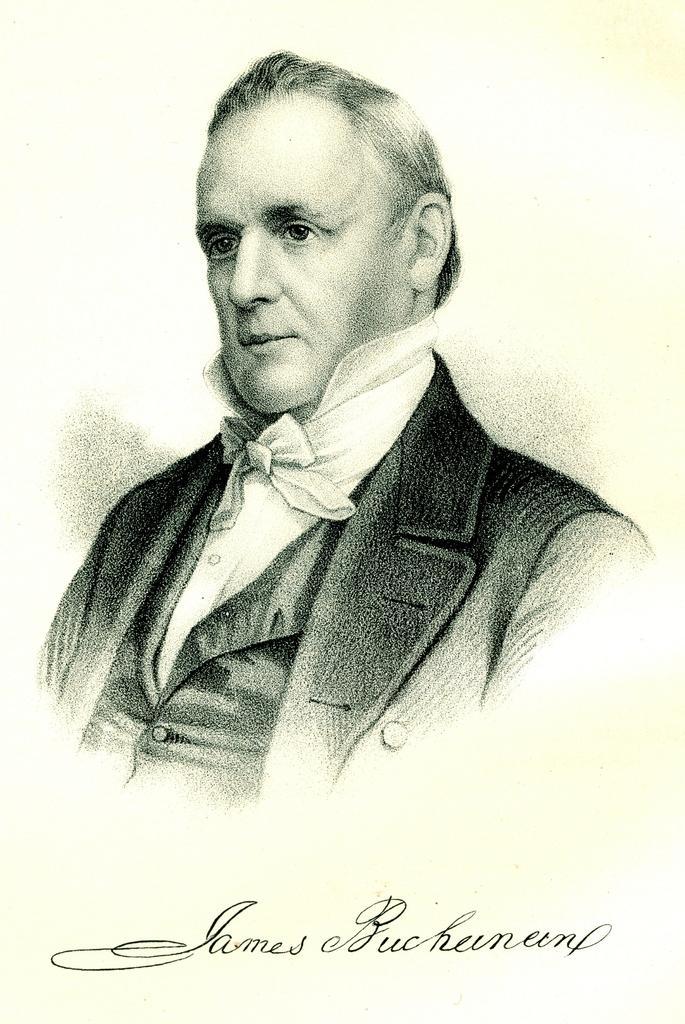How would you summarize this image in a sentence or two? In this image I can see the painting of the person with the dress and something is written on it. 